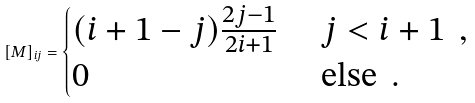Convert formula to latex. <formula><loc_0><loc_0><loc_500><loc_500>[ { M } ] _ { i j } = \begin{cases} ( i + 1 - j ) \frac { 2 j - 1 } { 2 i + 1 } & \text { $j<i+1$ } \, , \\ 0 & \text { else } \, . \end{cases}</formula> 